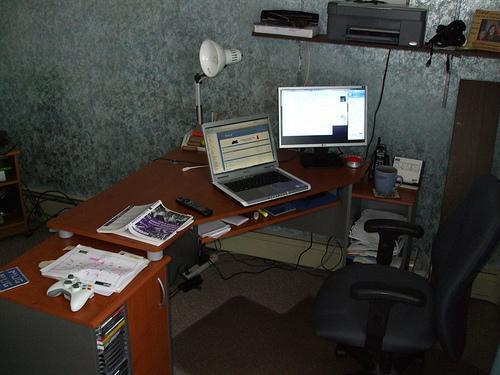How many computers are there?
Give a very brief answer. 2. 